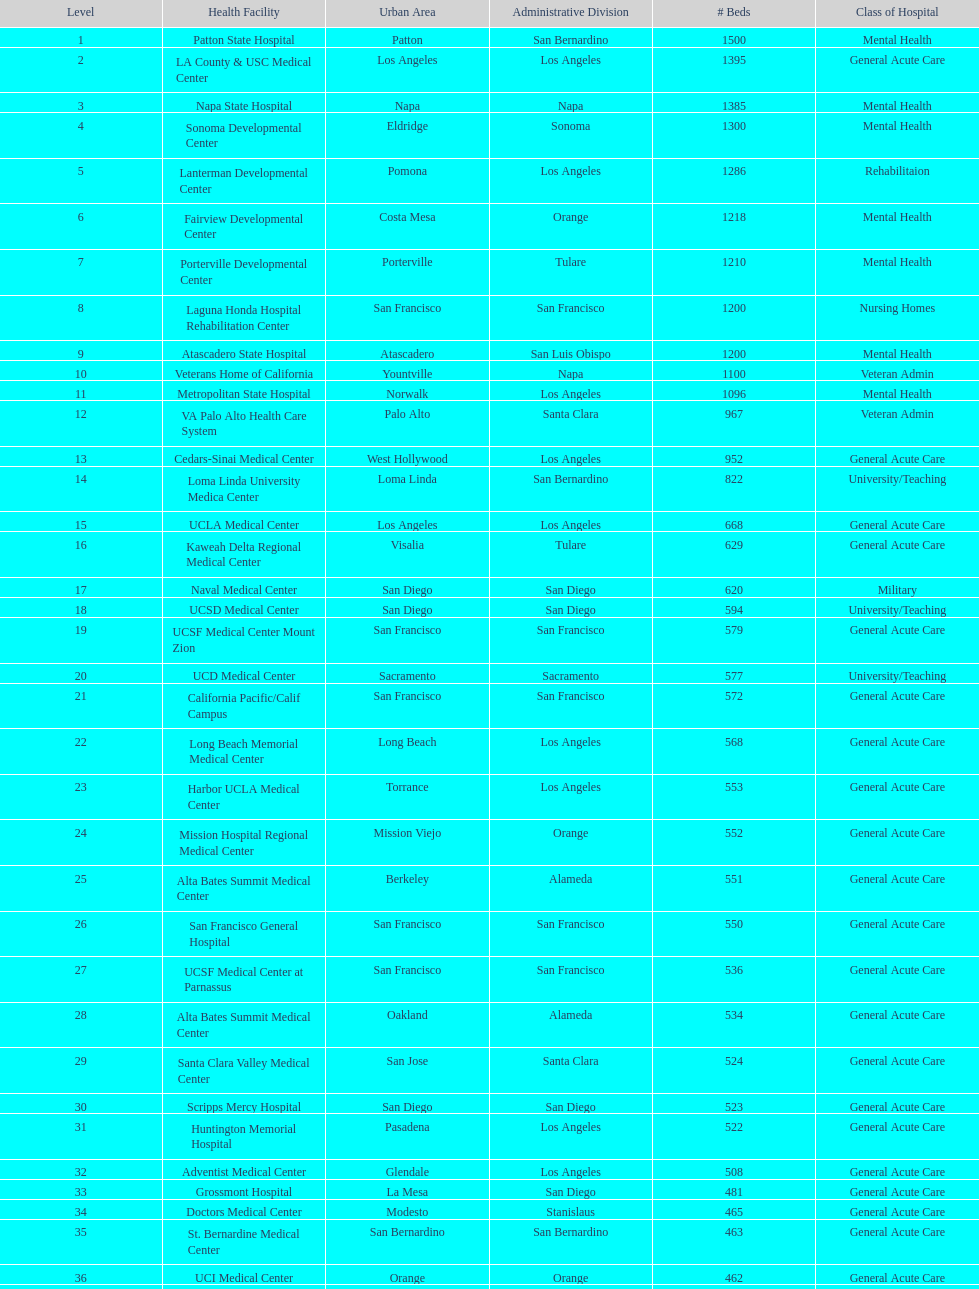Which type of hospitals are the same as grossmont hospital? General Acute Care. 